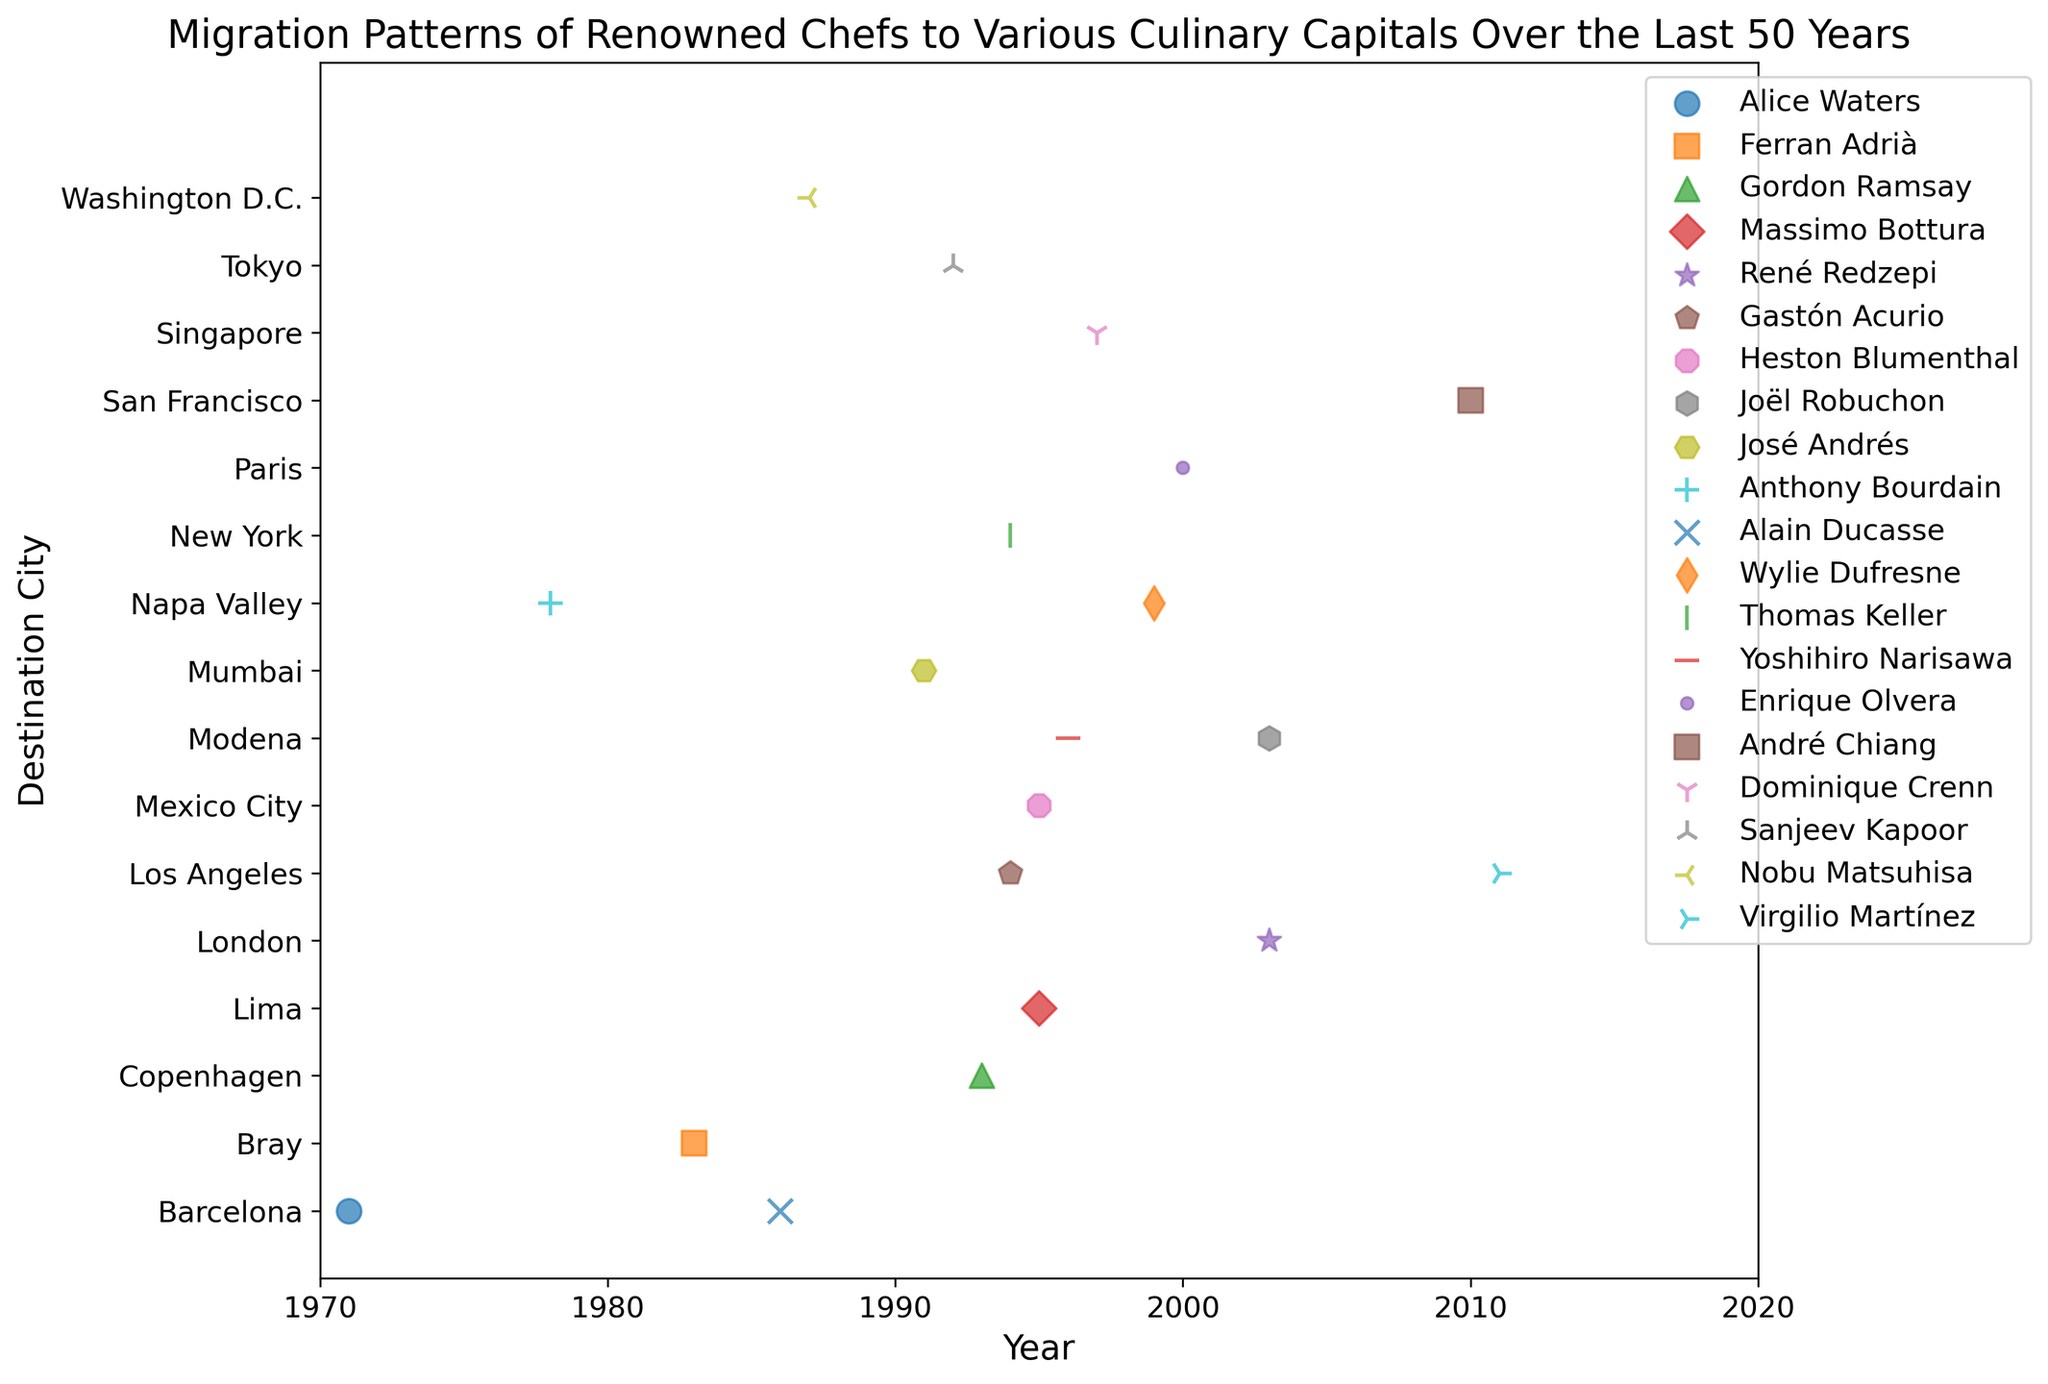How many chefs migrated to new culinary capitals in the 1990s? We observe the scatter plot and count the number of chefs whose migration years fall within the 1990s (1990 to 1999). According to the data points, there are 6 chefs (Gordon Ramsay, Gastón Acurio, José Andrés, Heston Blumenthal, Wylie Dufresne, Dominique Crenn)
Answer: 6 Which chef migrated to Tokyo and in which year? We identify the data point associated with Tokyo and check which chef is linked to that marker. There are two markers for Tokyo, associated with Joël Robuchon in 2003 and Yoshihiro Narisawa in 1996
Answer: Joël Robuchon (2003), Yoshihiro Narisawa (1996) Which city received chefs from the highest number of origin countries? To answer this, we need to observe the scatter plot and count the number of unique origin countries for each destination city. Paris, Tokyo, and New York each received chefs from different origin countries (USA, France, Japan)
Answer: Paris, Tokyo, New York What is the range of years during which chefs migrated to Singapore? Check the data points related to Singapore and observe the earliest and latest year for migration. The migrations happened in 2010
Answer: 2010 Compare the number of chefs who migrated to European cities versus those who migrated to American cities Identify the destination cities by continent. European cities are Paris, Barcelona, London, Modena, and Copenhagen. American cities are Washington D.C., New York, Napa Valley, San Francisco, Los Angeles, and Lima. Count the scatter plot markers for each group. 5 chefs migrated to European cities and 6 chefs migrated to American cities
Answer: European: 5, American: 6 Which chef's migration to their destination city occurred earliest, and what is the destination city? Find the earliest year in the scatter plot data. The earliest migration happened in 1971, and the chef is Alice Waters whose destination city is Paris
Answer: Alice Waters, Paris (1971) Find the average migration year for chefs who moved to Tokyo Identify the chefs who migrated to Tokyo and their respective years (Joël Robuchon in 2003 and Yoshihiro Narisawa in 1996). Calculate the average of these years: (2003 + 1996) / 2
Answer: 1999.5 Which destination city had the highest number of chefs arriving in the same year, and what year was it? Observe the scatter plot to find the highest count of chefs arriving in a specific city in the same year. Two chefs migrated to Tokyo in 2003 (Joël Robuchon)
Answer: Tokyo, 2003 What is the median year of migration for chefs heading to Paris? Identify the years of migrations to Paris (1971 and 1986) and find the median. Since there are only two data points, the median is the average of these years: (1971 + 1986) / 2
Answer: 1978.5 